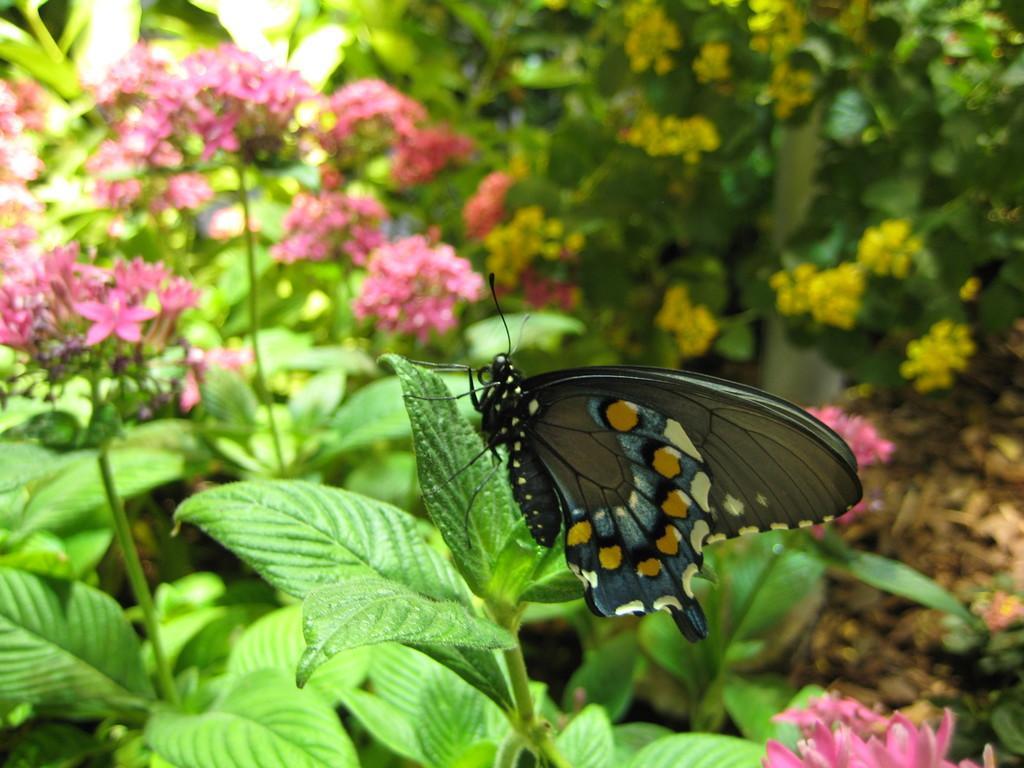Please provide a concise description of this image. In this image I see a butterfly on this leaf and I see that the butterfly is of black, white, blue and yellow in color and I see the plants on which there are flowers which are of pink and yellow in color. 